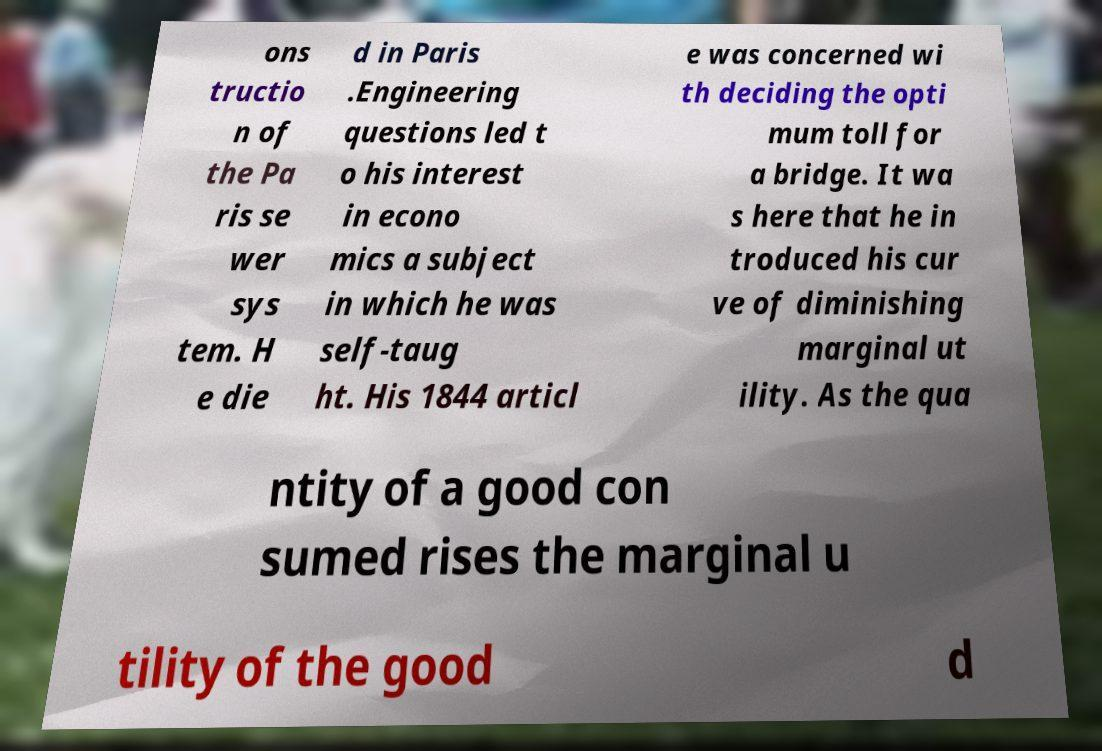What messages or text are displayed in this image? I need them in a readable, typed format. ons tructio n of the Pa ris se wer sys tem. H e die d in Paris .Engineering questions led t o his interest in econo mics a subject in which he was self-taug ht. His 1844 articl e was concerned wi th deciding the opti mum toll for a bridge. It wa s here that he in troduced his cur ve of diminishing marginal ut ility. As the qua ntity of a good con sumed rises the marginal u tility of the good d 